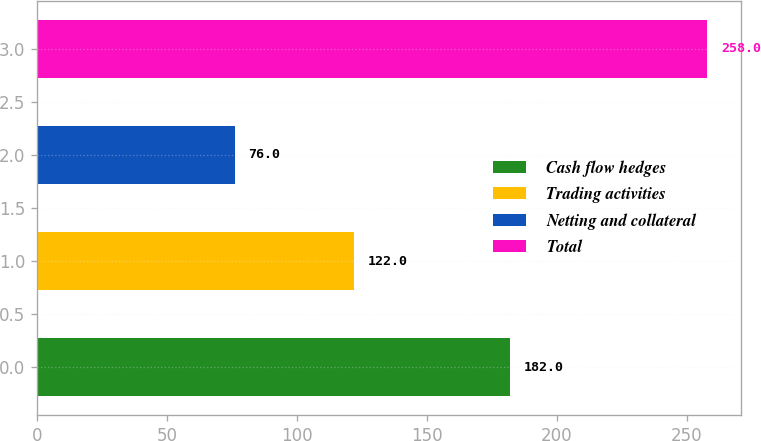<chart> <loc_0><loc_0><loc_500><loc_500><bar_chart><fcel>Cash flow hedges<fcel>Trading activities<fcel>Netting and collateral<fcel>Total<nl><fcel>182<fcel>122<fcel>76<fcel>258<nl></chart> 